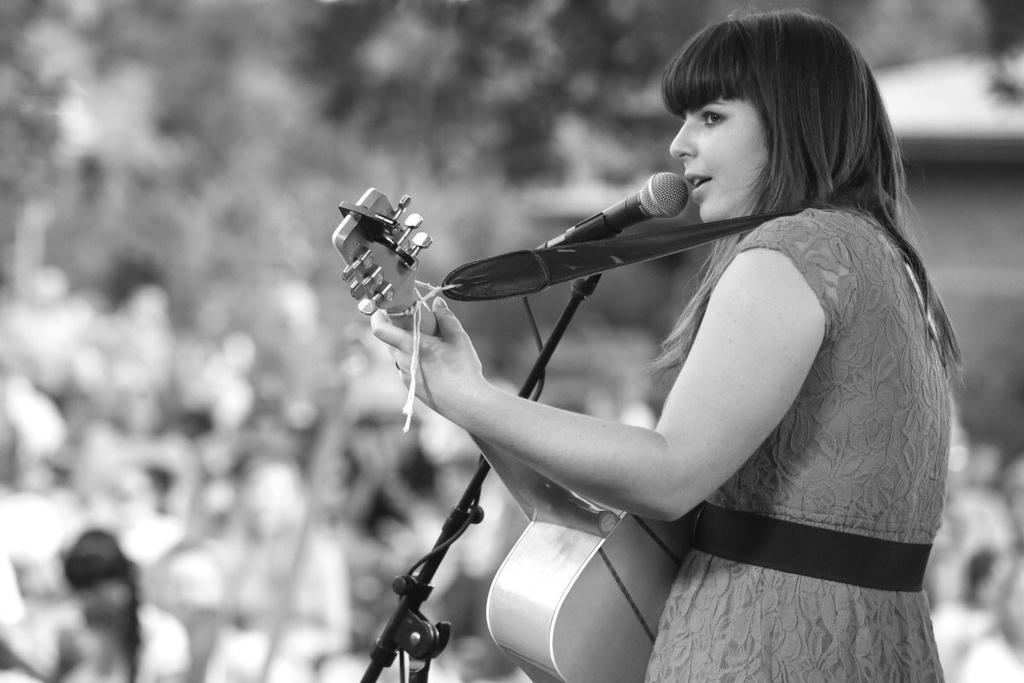Can you describe this image briefly? Here in this picture we can see a woman singing a song with a microphone in front of her and she is also holding a guitar in her hand present over there. 